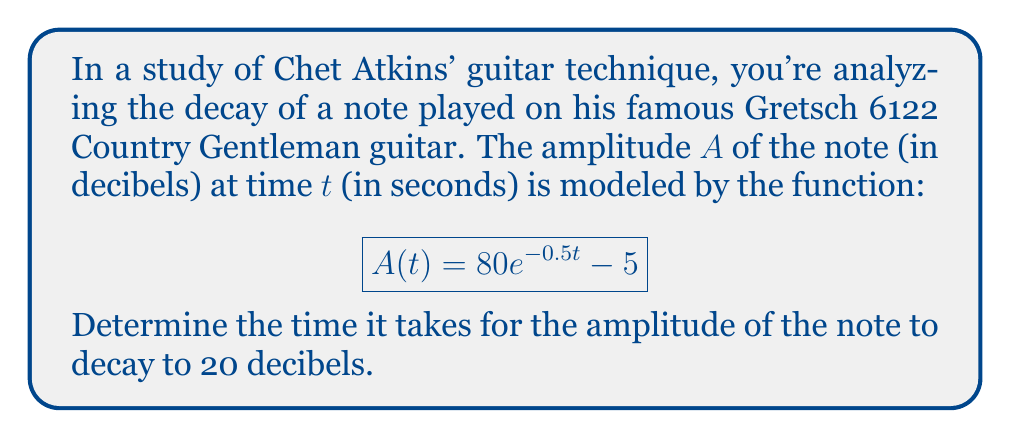Show me your answer to this math problem. To solve this problem, we'll follow these steps:

1) We need to find $t$ when $A(t) = 20$. So, we set up the equation:

   $$20 = 80e^{-0.5t} - 5$$

2) First, add 5 to both sides:

   $$25 = 80e^{-0.5t}$$

3) Divide both sides by 80:

   $$\frac{25}{80} = e^{-0.5t}$$

4) Take the natural logarithm of both sides:

   $$\ln(\frac{25}{80}) = \ln(e^{-0.5t})$$

5) Simplify the right side using the properties of logarithms:

   $$\ln(\frac{25}{80}) = -0.5t$$

6) Divide both sides by -0.5:

   $$\frac{\ln(\frac{25}{80})}{-0.5} = t$$

7) Calculate the value:

   $$t \approx 2.31$$

Therefore, it takes approximately 2.31 seconds for the note to decay to 20 decibels.
Answer: $2.31$ seconds 